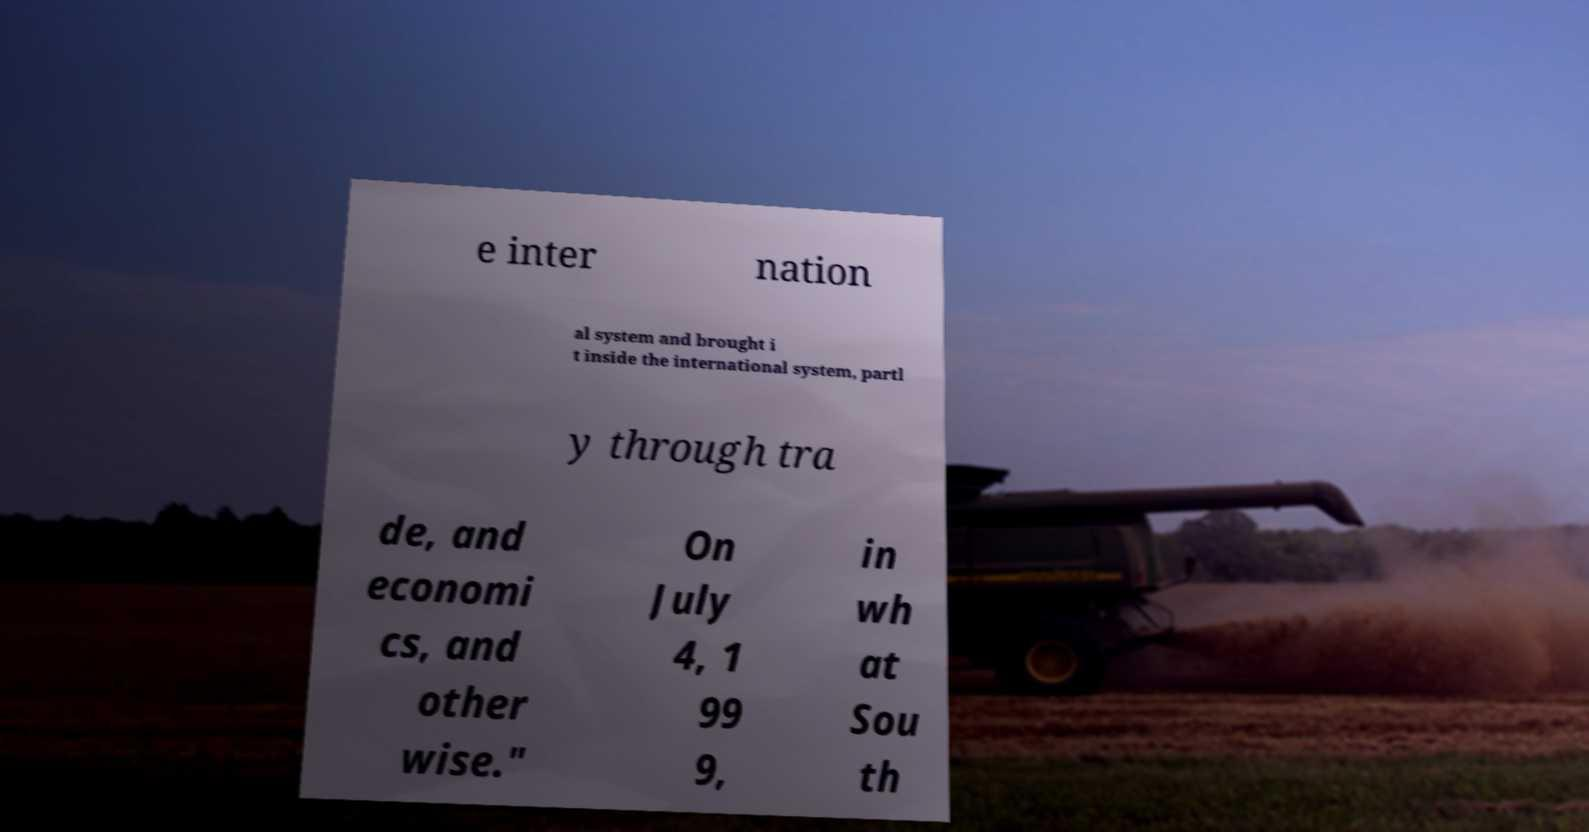Can you accurately transcribe the text from the provided image for me? e inter nation al system and brought i t inside the international system, partl y through tra de, and economi cs, and other wise." On July 4, 1 99 9, in wh at Sou th 